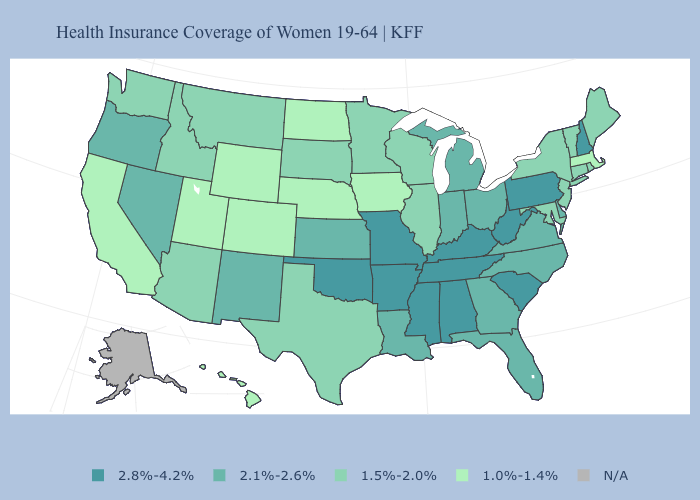Does the first symbol in the legend represent the smallest category?
Short answer required. No. Name the states that have a value in the range 1.0%-1.4%?
Concise answer only. California, Colorado, Hawaii, Iowa, Massachusetts, Nebraska, North Dakota, Utah, Wyoming. What is the value of Florida?
Concise answer only. 2.1%-2.6%. What is the value of Virginia?
Keep it brief. 2.1%-2.6%. Name the states that have a value in the range 1.0%-1.4%?
Quick response, please. California, Colorado, Hawaii, Iowa, Massachusetts, Nebraska, North Dakota, Utah, Wyoming. What is the lowest value in states that border Utah?
Answer briefly. 1.0%-1.4%. What is the value of Virginia?
Answer briefly. 2.1%-2.6%. Among the states that border Massachusetts , which have the highest value?
Answer briefly. New Hampshire. Among the states that border Georgia , does Florida have the highest value?
Write a very short answer. No. What is the value of New York?
Quick response, please. 1.5%-2.0%. What is the highest value in states that border Wyoming?
Concise answer only. 1.5%-2.0%. Is the legend a continuous bar?
Keep it brief. No. Which states hav the highest value in the South?
Give a very brief answer. Alabama, Arkansas, Kentucky, Mississippi, Oklahoma, South Carolina, Tennessee, West Virginia. What is the value of Maryland?
Short answer required. 1.5%-2.0%. What is the lowest value in states that border New Jersey?
Give a very brief answer. 1.5%-2.0%. 